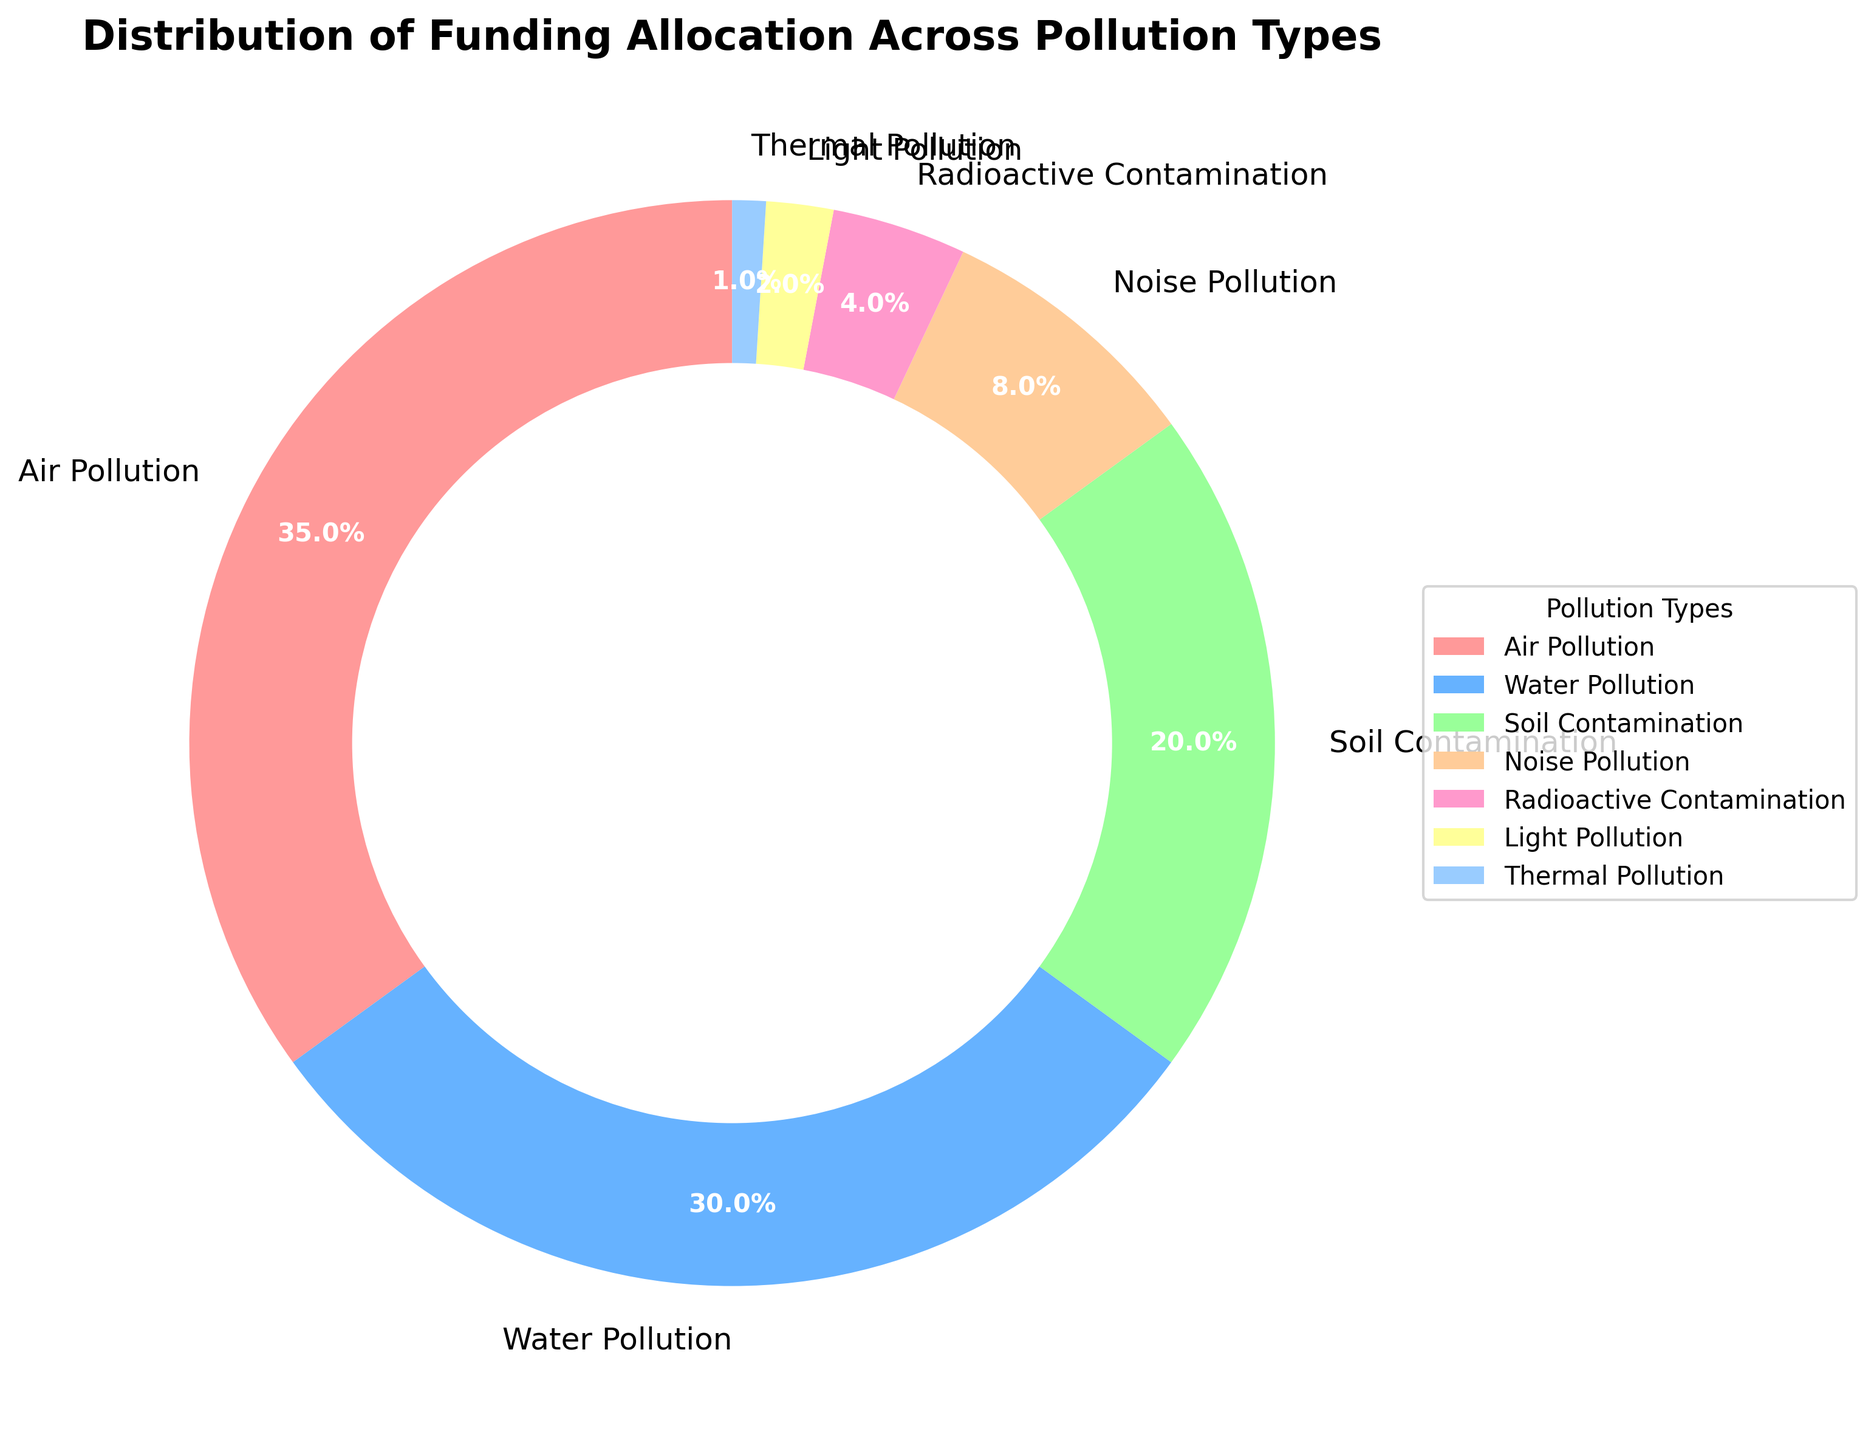Which pollution type received the most funding allocation? The pie chart shows different funding allocations for pollution types. The largest segment represents Air Pollution at 35%.
Answer: Air Pollution How much more funding is allocated to Air Pollution compared to Soil Contamination? Air Pollution has 35% allocation, while Soil Contamination has 20%. The difference is 35% - 20%.
Answer: 15% What is the combined funding allocation for Water Pollution and Noise Pollution? Water Pollution has 30% and Noise Pollution has 8%. Adding these gives 30% + 8%.
Answer: 38% Which two pollution types received the smallest funding allocations? The pie chart segments indicate that Light Pollution received 2% and Thermal Pollution received 1%, making them the smallest allocations.
Answer: Light Pollution and Thermal Pollution What is the average funding allocation for Air, Water, and Soil pollution? Air, Water, and Soil pollution have 35%, 30%, and 20% respectively. Their sum is 35 + 30 + 20 = 85. Dividing by 3 gives 85/3.
Answer: 28.33% Is the funding allocation for Radioactive Contamination and Light Pollution combined greater than that for Noise Pollution? Radioactive Contamination has 4% and Light Pollution has 2%, summing to 6%. Noise Pollution alone has 8%, which is greater than 6%.
Answer: No By how much does the funding for Water Pollution exceed that for Radioactive Contamination? Water Pollution has a 30% allocation, and Radioactive Contamination has 4%. The difference is 30% - 4%.
Answer: 26% Which pollution type has a funding allocation closest to 10%? The pie chart shows Noise Pollution with an 8% allocation, which is closest to 10%.
Answer: Noise Pollution What is the total funding allocation for the three least funded pollution types? Light Pollution (2%), Thermal Pollution (1%), and Radioactive Contamination (4%) sum to 2% + 1% + 4%.
Answer: 7% Compare the funding allocated to Noise Pollution and Radioactive Contamination. Which one is higher and by how much? Noise Pollution received 8%, while Radioactive Contamination received 4%. The difference is 8% - 4%.
Answer: Noise Pollution by 4% 